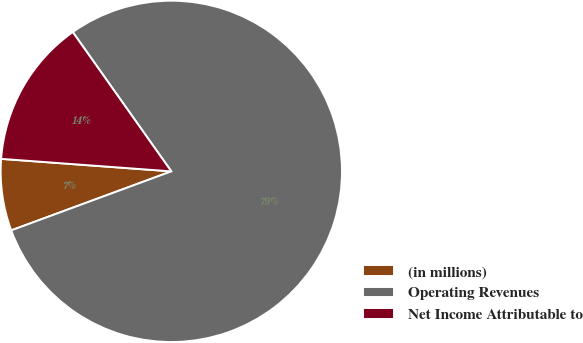Convert chart. <chart><loc_0><loc_0><loc_500><loc_500><pie_chart><fcel>(in millions)<fcel>Operating Revenues<fcel>Net Income Attributable to<nl><fcel>6.79%<fcel>79.18%<fcel>14.03%<nl></chart> 